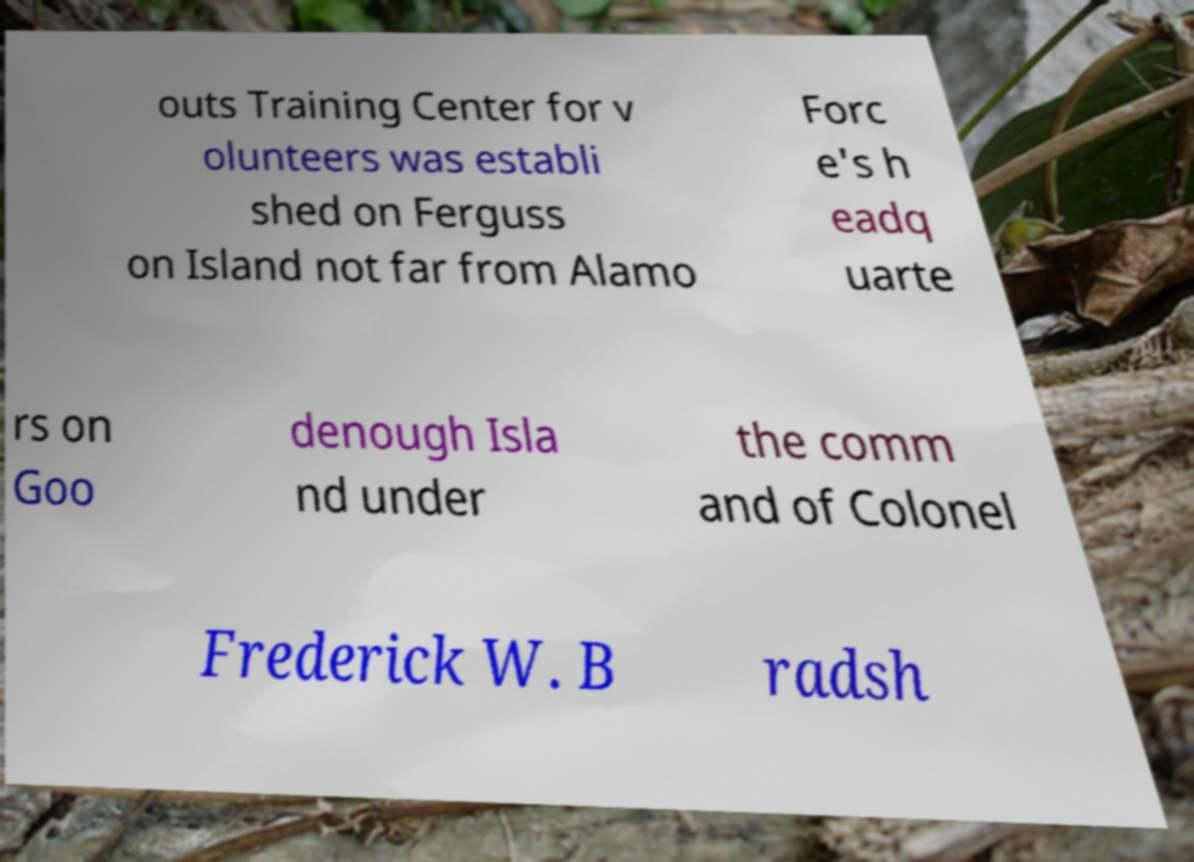Please identify and transcribe the text found in this image. outs Training Center for v olunteers was establi shed on Ferguss on Island not far from Alamo Forc e's h eadq uarte rs on Goo denough Isla nd under the comm and of Colonel Frederick W. B radsh 